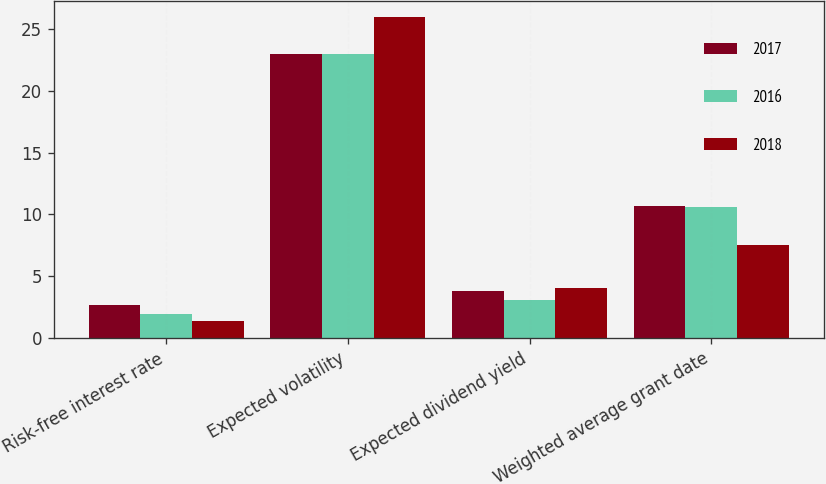Convert chart. <chart><loc_0><loc_0><loc_500><loc_500><stacked_bar_chart><ecel><fcel>Risk-free interest rate<fcel>Expected volatility<fcel>Expected dividend yield<fcel>Weighted average grant date<nl><fcel>2017<fcel>2.64<fcel>23<fcel>3.8<fcel>10.67<nl><fcel>2016<fcel>1.97<fcel>23<fcel>3.1<fcel>10.56<nl><fcel>2018<fcel>1.37<fcel>26<fcel>4<fcel>7.51<nl></chart> 